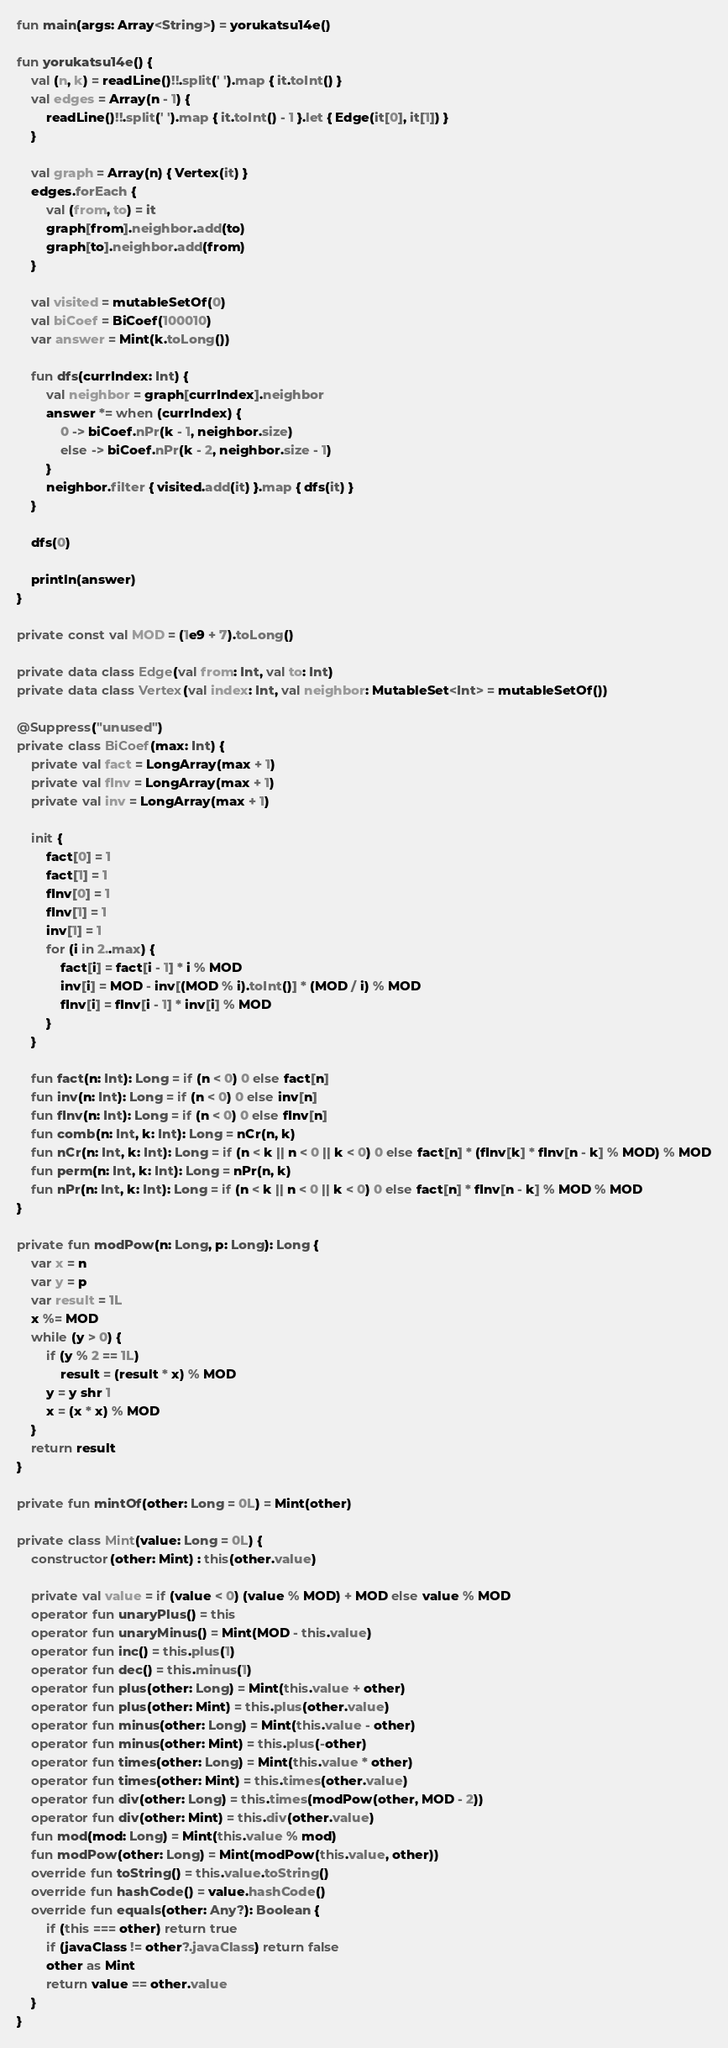<code> <loc_0><loc_0><loc_500><loc_500><_Kotlin_>fun main(args: Array<String>) = yorukatsu14e()

fun yorukatsu14e() {
    val (n, k) = readLine()!!.split(' ').map { it.toInt() }
    val edges = Array(n - 1) {
        readLine()!!.split(' ').map { it.toInt() - 1 }.let { Edge(it[0], it[1]) }
    }

    val graph = Array(n) { Vertex(it) }
    edges.forEach {
        val (from, to) = it
        graph[from].neighbor.add(to)
        graph[to].neighbor.add(from)
    }

    val visited = mutableSetOf(0)
    val biCoef = BiCoef(100010)
    var answer = Mint(k.toLong())

    fun dfs(currIndex: Int) {
        val neighbor = graph[currIndex].neighbor
        answer *= when (currIndex) {
            0 -> biCoef.nPr(k - 1, neighbor.size)
            else -> biCoef.nPr(k - 2, neighbor.size - 1)
        }
        neighbor.filter { visited.add(it) }.map { dfs(it) }
    }

    dfs(0)

    println(answer)
}

private const val MOD = (1e9 + 7).toLong()

private data class Edge(val from: Int, val to: Int)
private data class Vertex(val index: Int, val neighbor: MutableSet<Int> = mutableSetOf())

@Suppress("unused")
private class BiCoef(max: Int) {
    private val fact = LongArray(max + 1)
    private val fInv = LongArray(max + 1)
    private val inv = LongArray(max + 1)

    init {
        fact[0] = 1
        fact[1] = 1
        fInv[0] = 1
        fInv[1] = 1
        inv[1] = 1
        for (i in 2..max) {
            fact[i] = fact[i - 1] * i % MOD
            inv[i] = MOD - inv[(MOD % i).toInt()] * (MOD / i) % MOD
            fInv[i] = fInv[i - 1] * inv[i] % MOD
        }
    }

    fun fact(n: Int): Long = if (n < 0) 0 else fact[n]
    fun inv(n: Int): Long = if (n < 0) 0 else inv[n]
    fun fInv(n: Int): Long = if (n < 0) 0 else fInv[n]
    fun comb(n: Int, k: Int): Long = nCr(n, k)
    fun nCr(n: Int, k: Int): Long = if (n < k || n < 0 || k < 0) 0 else fact[n] * (fInv[k] * fInv[n - k] % MOD) % MOD
    fun perm(n: Int, k: Int): Long = nPr(n, k)
    fun nPr(n: Int, k: Int): Long = if (n < k || n < 0 || k < 0) 0 else fact[n] * fInv[n - k] % MOD % MOD
}

private fun modPow(n: Long, p: Long): Long {
    var x = n
    var y = p
    var result = 1L
    x %= MOD
    while (y > 0) {
        if (y % 2 == 1L)
            result = (result * x) % MOD
        y = y shr 1
        x = (x * x) % MOD
    }
    return result
}

private fun mintOf(other: Long = 0L) = Mint(other)

private class Mint(value: Long = 0L) {
    constructor(other: Mint) : this(other.value)

    private val value = if (value < 0) (value % MOD) + MOD else value % MOD
    operator fun unaryPlus() = this
    operator fun unaryMinus() = Mint(MOD - this.value)
    operator fun inc() = this.plus(1)
    operator fun dec() = this.minus(1)
    operator fun plus(other: Long) = Mint(this.value + other)
    operator fun plus(other: Mint) = this.plus(other.value)
    operator fun minus(other: Long) = Mint(this.value - other)
    operator fun minus(other: Mint) = this.plus(-other)
    operator fun times(other: Long) = Mint(this.value * other)
    operator fun times(other: Mint) = this.times(other.value)
    operator fun div(other: Long) = this.times(modPow(other, MOD - 2))
    operator fun div(other: Mint) = this.div(other.value)
    fun mod(mod: Long) = Mint(this.value % mod)
    fun modPow(other: Long) = Mint(modPow(this.value, other))
    override fun toString() = this.value.toString()
    override fun hashCode() = value.hashCode()
    override fun equals(other: Any?): Boolean {
        if (this === other) return true
        if (javaClass != other?.javaClass) return false
        other as Mint
        return value == other.value
    }
}
</code> 